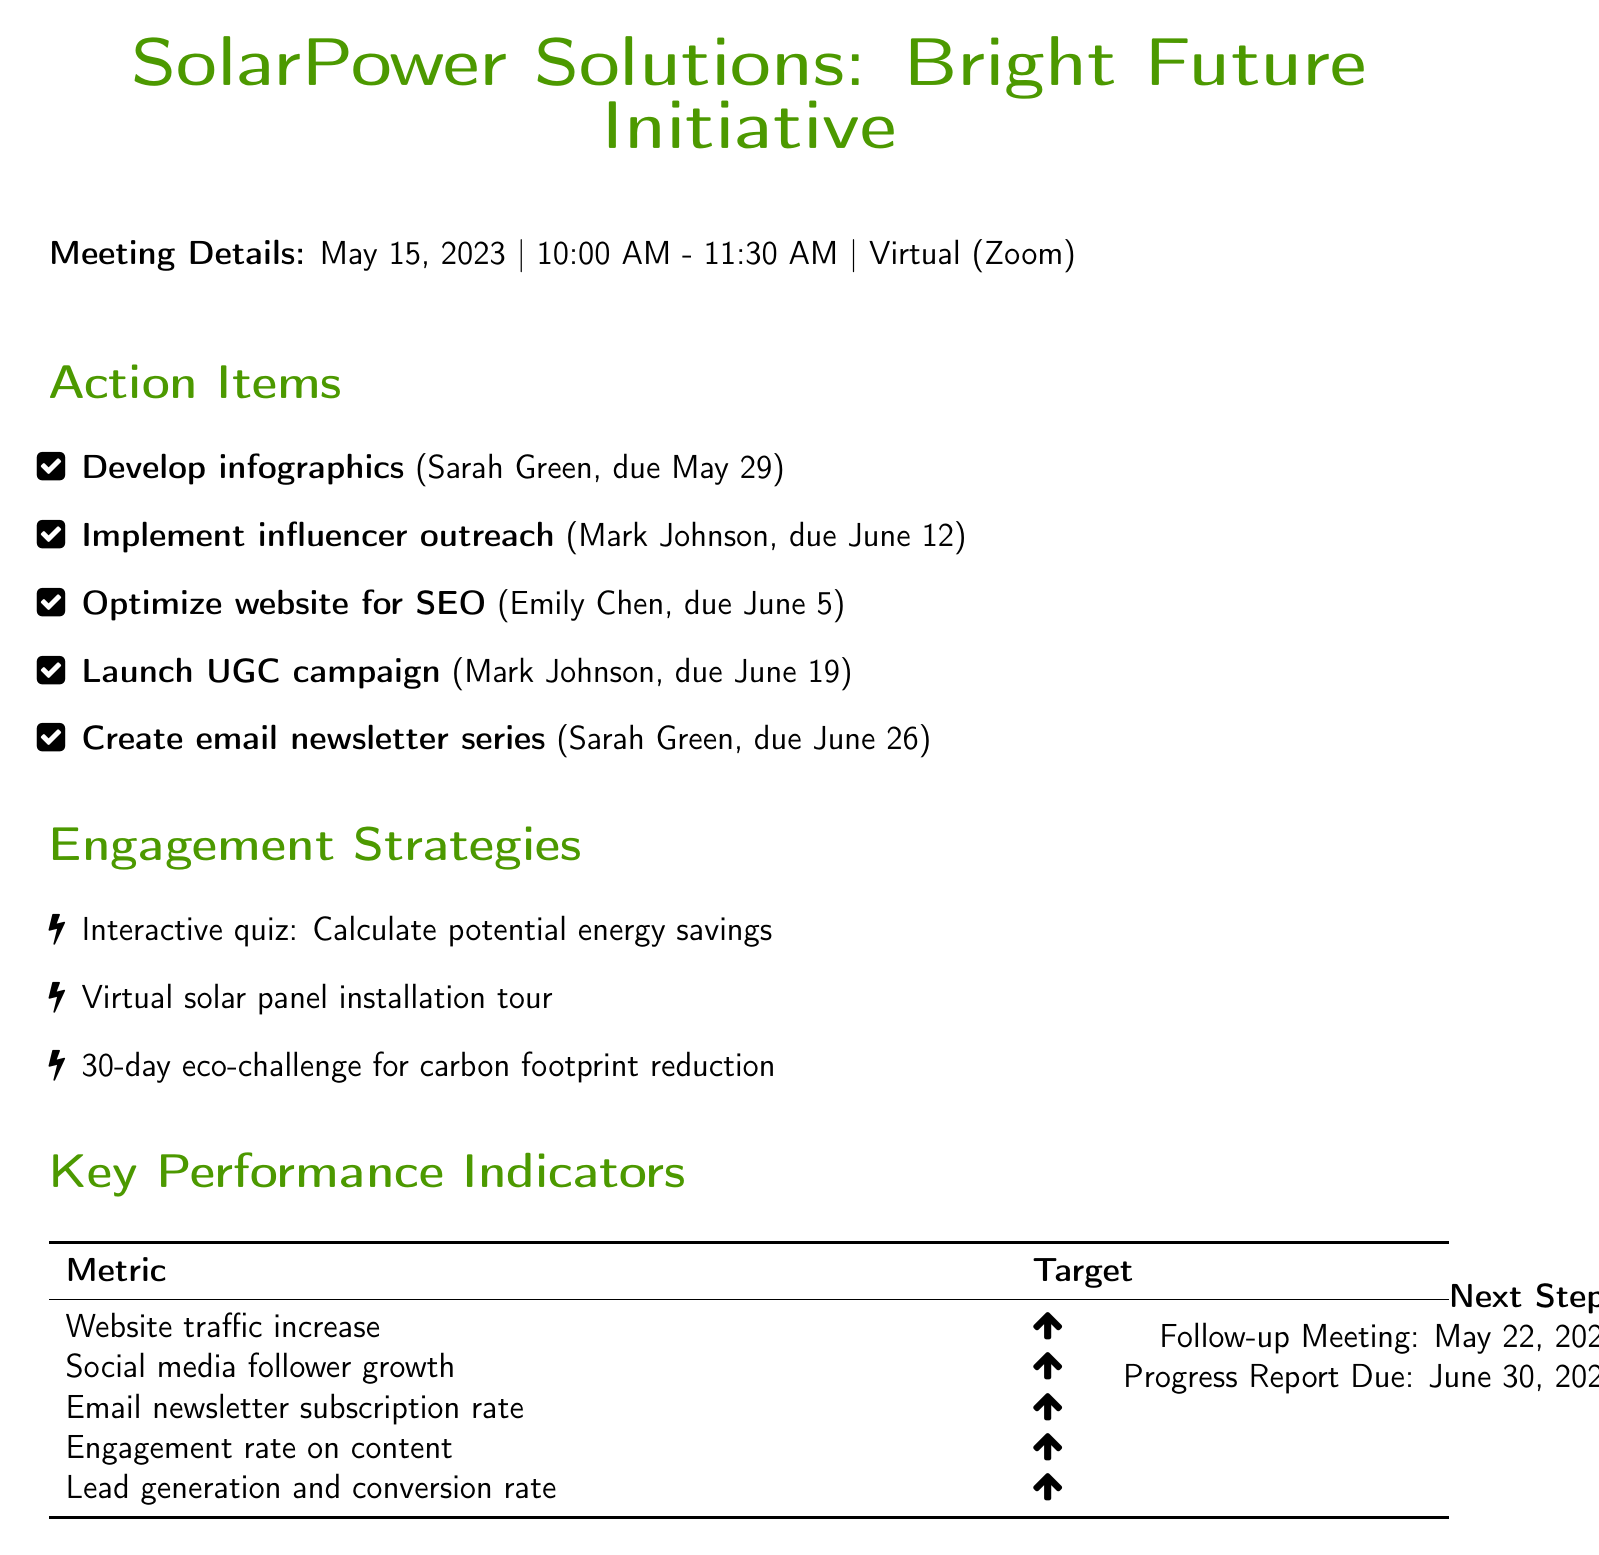What is the date of the meeting? The date of the meeting is specified under meeting details.
Answer: 2023-05-15 Who is responsible for developing infographics? The person's name is listed next to the task in the action items section.
Answer: Sarah Green What is the deadline for optimizing website content for SEO? The deadline is stated in the action items section next to the corresponding task.
Answer: 2023-06-05 Which strategy involves a quiz? This strategy is detailed under the engagement strategies section.
Answer: Interactive quiz When is the follow-up meeting scheduled? The date of the follow-up meeting is indicated in the next steps section.
Answer: 2023-05-22 What is the campaign name for SolarPower Solutions? The campaign name is mentioned in the client information part of the document.
Answer: Bright Future Initiative How many parts will the email newsletter series consist of? This information is mentioned in the action items under the task description.
Answer: 5-part What performance metric focuses on social media growth? This metric is listed under the key performance indicators section.
Answer: Social media follower growth 